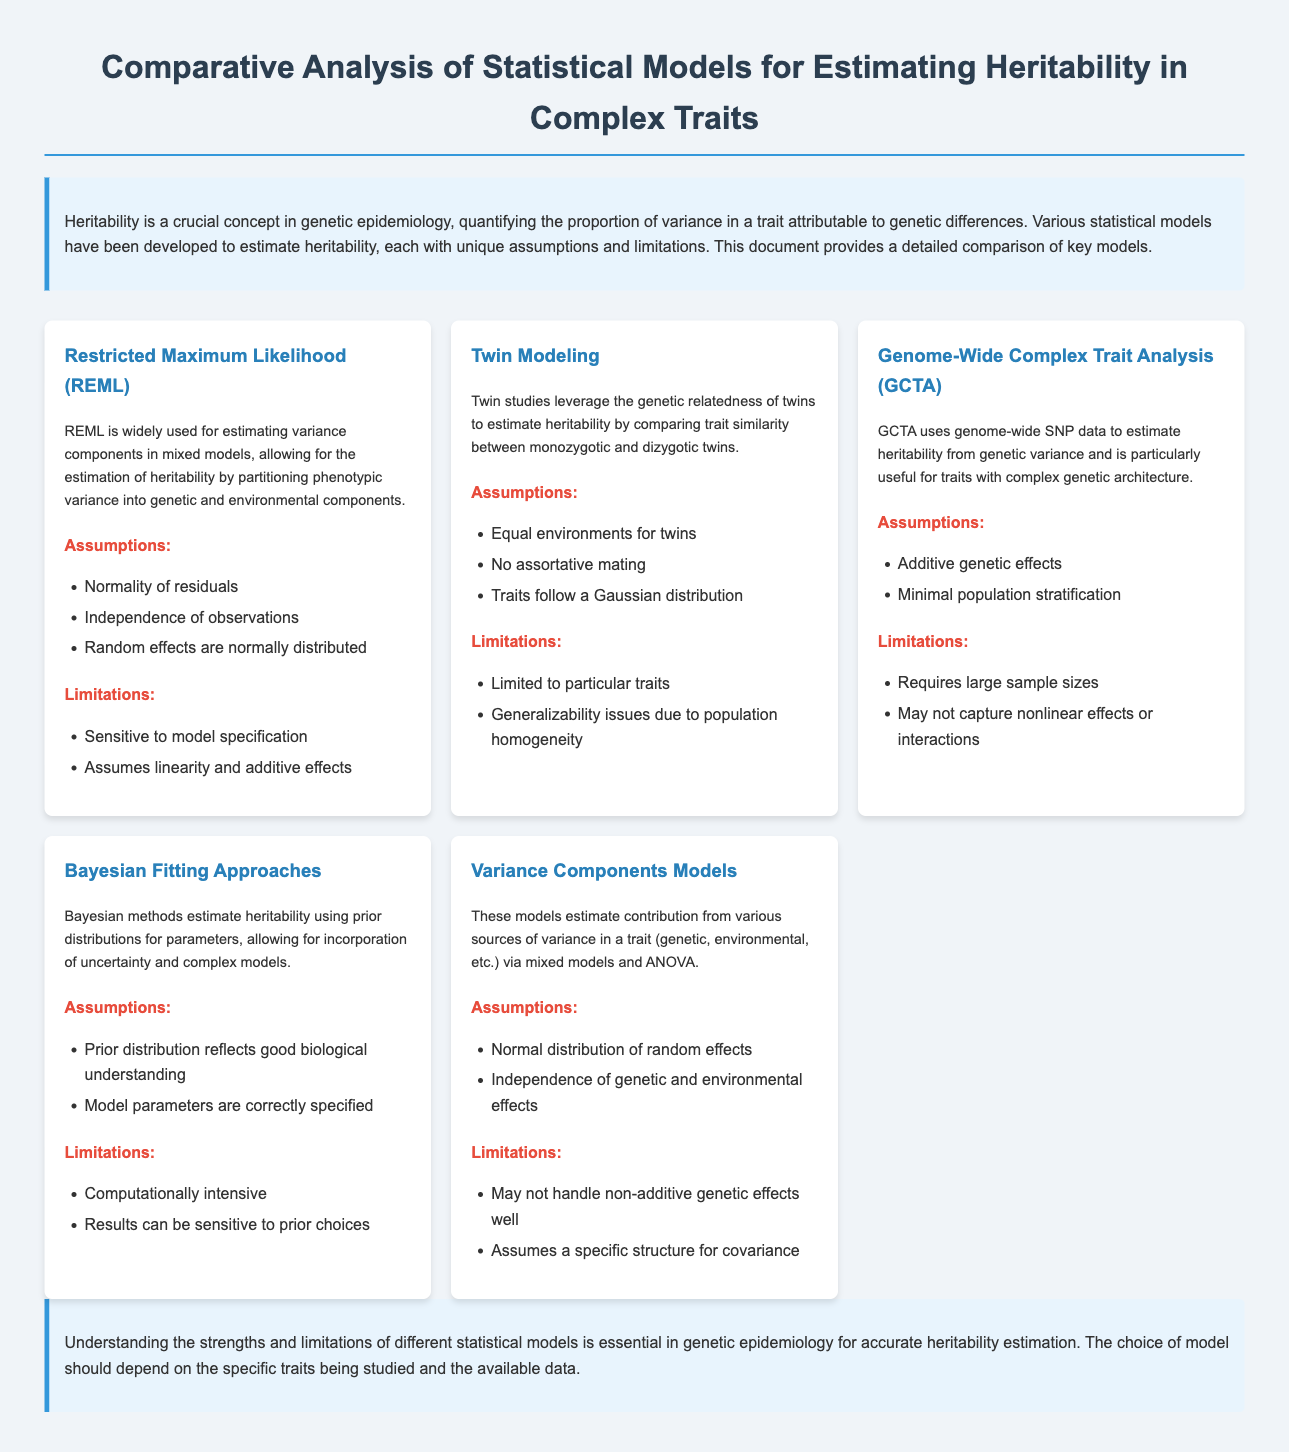What is the title of the document? The title is prominently displayed at the top of the document and indicates the main subject matter.
Answer: Comparative Analysis of Statistical Models for Estimating Heritability in Complex Traits What statistical model uses genome-wide SNP data? This information is derived from the description of the GCTA model in the document.
Answer: GCTA Which model is sensitive to model specification? The limitations section for the REML model highlights this issue directly.
Answer: REML How many assumptions does the Twin Modeling approach have? By counting the listed assumptions under Twin Modeling in the document, we can find this answer.
Answer: Three What statistical model is described as computationally intensive? This is stated in the limitations section of the Bayesian Fitting Approaches.
Answer: Bayesian Fitting Approaches What genetic epidemiology concept is quantified by heritability? The introductory paragraph mentions what heritability quantifies.
Answer: Variance in a trait Which approach assumes that traits follow a Gaussian distribution? This assumption is specifically listed for Twin Modeling within the document.
Answer: Twin Modeling What is a critical characteristic required by the GCTA method? The assumptions list for GCTA provides this information regarding genetic effects.
Answer: Additive genetic effects What is the color of the header for assumptions in the document? The styling of the text for assumptions indicates its color, derived from the document's CSS.
Answer: Red 